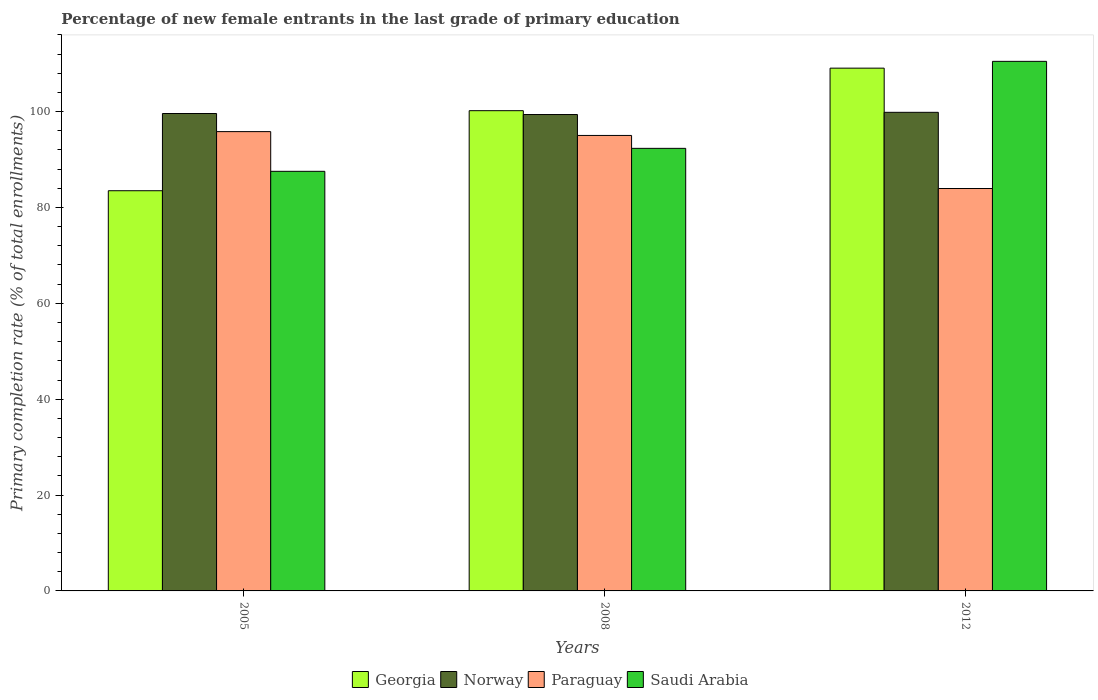How many different coloured bars are there?
Offer a very short reply. 4. How many bars are there on the 1st tick from the left?
Make the answer very short. 4. What is the label of the 2nd group of bars from the left?
Ensure brevity in your answer.  2008. In how many cases, is the number of bars for a given year not equal to the number of legend labels?
Your answer should be very brief. 0. What is the percentage of new female entrants in Georgia in 2008?
Your answer should be very brief. 100.19. Across all years, what is the maximum percentage of new female entrants in Paraguay?
Your answer should be very brief. 95.83. Across all years, what is the minimum percentage of new female entrants in Norway?
Offer a terse response. 99.39. What is the total percentage of new female entrants in Paraguay in the graph?
Provide a succinct answer. 274.82. What is the difference between the percentage of new female entrants in Norway in 2005 and that in 2012?
Make the answer very short. -0.25. What is the difference between the percentage of new female entrants in Georgia in 2008 and the percentage of new female entrants in Saudi Arabia in 2005?
Make the answer very short. 12.65. What is the average percentage of new female entrants in Paraguay per year?
Keep it short and to the point. 91.61. In the year 2008, what is the difference between the percentage of new female entrants in Saudi Arabia and percentage of new female entrants in Georgia?
Offer a very short reply. -7.86. What is the ratio of the percentage of new female entrants in Georgia in 2005 to that in 2012?
Keep it short and to the point. 0.77. Is the percentage of new female entrants in Norway in 2005 less than that in 2008?
Offer a terse response. No. What is the difference between the highest and the second highest percentage of new female entrants in Paraguay?
Your answer should be very brief. 0.8. What is the difference between the highest and the lowest percentage of new female entrants in Paraguay?
Ensure brevity in your answer.  11.87. In how many years, is the percentage of new female entrants in Paraguay greater than the average percentage of new female entrants in Paraguay taken over all years?
Make the answer very short. 2. Is the sum of the percentage of new female entrants in Norway in 2005 and 2008 greater than the maximum percentage of new female entrants in Georgia across all years?
Your answer should be compact. Yes. What does the 1st bar from the left in 2005 represents?
Your answer should be compact. Georgia. How many bars are there?
Your answer should be very brief. 12. How many years are there in the graph?
Your response must be concise. 3. Does the graph contain grids?
Your answer should be very brief. No. Where does the legend appear in the graph?
Your answer should be very brief. Bottom center. How are the legend labels stacked?
Offer a very short reply. Horizontal. What is the title of the graph?
Offer a terse response. Percentage of new female entrants in the last grade of primary education. What is the label or title of the X-axis?
Your answer should be compact. Years. What is the label or title of the Y-axis?
Provide a short and direct response. Primary completion rate (% of total enrollments). What is the Primary completion rate (% of total enrollments) of Georgia in 2005?
Give a very brief answer. 83.49. What is the Primary completion rate (% of total enrollments) of Norway in 2005?
Your answer should be compact. 99.61. What is the Primary completion rate (% of total enrollments) of Paraguay in 2005?
Give a very brief answer. 95.83. What is the Primary completion rate (% of total enrollments) in Saudi Arabia in 2005?
Your response must be concise. 87.54. What is the Primary completion rate (% of total enrollments) in Georgia in 2008?
Offer a terse response. 100.19. What is the Primary completion rate (% of total enrollments) of Norway in 2008?
Offer a terse response. 99.39. What is the Primary completion rate (% of total enrollments) of Paraguay in 2008?
Your answer should be very brief. 95.03. What is the Primary completion rate (% of total enrollments) of Saudi Arabia in 2008?
Your answer should be very brief. 92.34. What is the Primary completion rate (% of total enrollments) in Georgia in 2012?
Keep it short and to the point. 109.07. What is the Primary completion rate (% of total enrollments) of Norway in 2012?
Your answer should be compact. 99.85. What is the Primary completion rate (% of total enrollments) of Paraguay in 2012?
Give a very brief answer. 83.96. What is the Primary completion rate (% of total enrollments) in Saudi Arabia in 2012?
Your response must be concise. 110.49. Across all years, what is the maximum Primary completion rate (% of total enrollments) in Georgia?
Ensure brevity in your answer.  109.07. Across all years, what is the maximum Primary completion rate (% of total enrollments) of Norway?
Your answer should be compact. 99.85. Across all years, what is the maximum Primary completion rate (% of total enrollments) in Paraguay?
Ensure brevity in your answer.  95.83. Across all years, what is the maximum Primary completion rate (% of total enrollments) in Saudi Arabia?
Give a very brief answer. 110.49. Across all years, what is the minimum Primary completion rate (% of total enrollments) in Georgia?
Ensure brevity in your answer.  83.49. Across all years, what is the minimum Primary completion rate (% of total enrollments) in Norway?
Keep it short and to the point. 99.39. Across all years, what is the minimum Primary completion rate (% of total enrollments) in Paraguay?
Offer a very short reply. 83.96. Across all years, what is the minimum Primary completion rate (% of total enrollments) of Saudi Arabia?
Offer a terse response. 87.54. What is the total Primary completion rate (% of total enrollments) in Georgia in the graph?
Give a very brief answer. 292.76. What is the total Primary completion rate (% of total enrollments) of Norway in the graph?
Your response must be concise. 298.85. What is the total Primary completion rate (% of total enrollments) of Paraguay in the graph?
Offer a terse response. 274.82. What is the total Primary completion rate (% of total enrollments) in Saudi Arabia in the graph?
Your answer should be compact. 290.37. What is the difference between the Primary completion rate (% of total enrollments) in Georgia in 2005 and that in 2008?
Ensure brevity in your answer.  -16.7. What is the difference between the Primary completion rate (% of total enrollments) in Norway in 2005 and that in 2008?
Offer a terse response. 0.21. What is the difference between the Primary completion rate (% of total enrollments) in Paraguay in 2005 and that in 2008?
Provide a short and direct response. 0.8. What is the difference between the Primary completion rate (% of total enrollments) in Saudi Arabia in 2005 and that in 2008?
Provide a succinct answer. -4.79. What is the difference between the Primary completion rate (% of total enrollments) of Georgia in 2005 and that in 2012?
Ensure brevity in your answer.  -25.57. What is the difference between the Primary completion rate (% of total enrollments) of Norway in 2005 and that in 2012?
Ensure brevity in your answer.  -0.25. What is the difference between the Primary completion rate (% of total enrollments) in Paraguay in 2005 and that in 2012?
Offer a terse response. 11.87. What is the difference between the Primary completion rate (% of total enrollments) of Saudi Arabia in 2005 and that in 2012?
Offer a terse response. -22.94. What is the difference between the Primary completion rate (% of total enrollments) of Georgia in 2008 and that in 2012?
Your response must be concise. -8.87. What is the difference between the Primary completion rate (% of total enrollments) of Norway in 2008 and that in 2012?
Your response must be concise. -0.46. What is the difference between the Primary completion rate (% of total enrollments) of Paraguay in 2008 and that in 2012?
Offer a very short reply. 11.07. What is the difference between the Primary completion rate (% of total enrollments) of Saudi Arabia in 2008 and that in 2012?
Ensure brevity in your answer.  -18.15. What is the difference between the Primary completion rate (% of total enrollments) in Georgia in 2005 and the Primary completion rate (% of total enrollments) in Norway in 2008?
Provide a short and direct response. -15.9. What is the difference between the Primary completion rate (% of total enrollments) in Georgia in 2005 and the Primary completion rate (% of total enrollments) in Paraguay in 2008?
Provide a short and direct response. -11.54. What is the difference between the Primary completion rate (% of total enrollments) in Georgia in 2005 and the Primary completion rate (% of total enrollments) in Saudi Arabia in 2008?
Your answer should be compact. -8.84. What is the difference between the Primary completion rate (% of total enrollments) of Norway in 2005 and the Primary completion rate (% of total enrollments) of Paraguay in 2008?
Provide a succinct answer. 4.58. What is the difference between the Primary completion rate (% of total enrollments) of Norway in 2005 and the Primary completion rate (% of total enrollments) of Saudi Arabia in 2008?
Your response must be concise. 7.27. What is the difference between the Primary completion rate (% of total enrollments) of Paraguay in 2005 and the Primary completion rate (% of total enrollments) of Saudi Arabia in 2008?
Your answer should be compact. 3.49. What is the difference between the Primary completion rate (% of total enrollments) in Georgia in 2005 and the Primary completion rate (% of total enrollments) in Norway in 2012?
Make the answer very short. -16.36. What is the difference between the Primary completion rate (% of total enrollments) in Georgia in 2005 and the Primary completion rate (% of total enrollments) in Paraguay in 2012?
Give a very brief answer. -0.46. What is the difference between the Primary completion rate (% of total enrollments) of Georgia in 2005 and the Primary completion rate (% of total enrollments) of Saudi Arabia in 2012?
Your answer should be very brief. -26.99. What is the difference between the Primary completion rate (% of total enrollments) in Norway in 2005 and the Primary completion rate (% of total enrollments) in Paraguay in 2012?
Provide a succinct answer. 15.65. What is the difference between the Primary completion rate (% of total enrollments) in Norway in 2005 and the Primary completion rate (% of total enrollments) in Saudi Arabia in 2012?
Give a very brief answer. -10.88. What is the difference between the Primary completion rate (% of total enrollments) of Paraguay in 2005 and the Primary completion rate (% of total enrollments) of Saudi Arabia in 2012?
Provide a succinct answer. -14.66. What is the difference between the Primary completion rate (% of total enrollments) of Georgia in 2008 and the Primary completion rate (% of total enrollments) of Norway in 2012?
Give a very brief answer. 0.34. What is the difference between the Primary completion rate (% of total enrollments) of Georgia in 2008 and the Primary completion rate (% of total enrollments) of Paraguay in 2012?
Provide a short and direct response. 16.24. What is the difference between the Primary completion rate (% of total enrollments) of Georgia in 2008 and the Primary completion rate (% of total enrollments) of Saudi Arabia in 2012?
Ensure brevity in your answer.  -10.29. What is the difference between the Primary completion rate (% of total enrollments) in Norway in 2008 and the Primary completion rate (% of total enrollments) in Paraguay in 2012?
Offer a terse response. 15.43. What is the difference between the Primary completion rate (% of total enrollments) in Norway in 2008 and the Primary completion rate (% of total enrollments) in Saudi Arabia in 2012?
Provide a succinct answer. -11.09. What is the difference between the Primary completion rate (% of total enrollments) of Paraguay in 2008 and the Primary completion rate (% of total enrollments) of Saudi Arabia in 2012?
Provide a short and direct response. -15.46. What is the average Primary completion rate (% of total enrollments) in Georgia per year?
Provide a succinct answer. 97.59. What is the average Primary completion rate (% of total enrollments) in Norway per year?
Make the answer very short. 99.62. What is the average Primary completion rate (% of total enrollments) in Paraguay per year?
Ensure brevity in your answer.  91.61. What is the average Primary completion rate (% of total enrollments) in Saudi Arabia per year?
Your response must be concise. 96.79. In the year 2005, what is the difference between the Primary completion rate (% of total enrollments) in Georgia and Primary completion rate (% of total enrollments) in Norway?
Provide a short and direct response. -16.11. In the year 2005, what is the difference between the Primary completion rate (% of total enrollments) of Georgia and Primary completion rate (% of total enrollments) of Paraguay?
Ensure brevity in your answer.  -12.33. In the year 2005, what is the difference between the Primary completion rate (% of total enrollments) of Georgia and Primary completion rate (% of total enrollments) of Saudi Arabia?
Your answer should be compact. -4.05. In the year 2005, what is the difference between the Primary completion rate (% of total enrollments) in Norway and Primary completion rate (% of total enrollments) in Paraguay?
Ensure brevity in your answer.  3.78. In the year 2005, what is the difference between the Primary completion rate (% of total enrollments) in Norway and Primary completion rate (% of total enrollments) in Saudi Arabia?
Your response must be concise. 12.06. In the year 2005, what is the difference between the Primary completion rate (% of total enrollments) of Paraguay and Primary completion rate (% of total enrollments) of Saudi Arabia?
Offer a very short reply. 8.28. In the year 2008, what is the difference between the Primary completion rate (% of total enrollments) of Georgia and Primary completion rate (% of total enrollments) of Norway?
Make the answer very short. 0.8. In the year 2008, what is the difference between the Primary completion rate (% of total enrollments) in Georgia and Primary completion rate (% of total enrollments) in Paraguay?
Your answer should be compact. 5.16. In the year 2008, what is the difference between the Primary completion rate (% of total enrollments) in Georgia and Primary completion rate (% of total enrollments) in Saudi Arabia?
Your answer should be very brief. 7.86. In the year 2008, what is the difference between the Primary completion rate (% of total enrollments) of Norway and Primary completion rate (% of total enrollments) of Paraguay?
Ensure brevity in your answer.  4.36. In the year 2008, what is the difference between the Primary completion rate (% of total enrollments) in Norway and Primary completion rate (% of total enrollments) in Saudi Arabia?
Make the answer very short. 7.06. In the year 2008, what is the difference between the Primary completion rate (% of total enrollments) in Paraguay and Primary completion rate (% of total enrollments) in Saudi Arabia?
Your response must be concise. 2.69. In the year 2012, what is the difference between the Primary completion rate (% of total enrollments) in Georgia and Primary completion rate (% of total enrollments) in Norway?
Ensure brevity in your answer.  9.22. In the year 2012, what is the difference between the Primary completion rate (% of total enrollments) in Georgia and Primary completion rate (% of total enrollments) in Paraguay?
Offer a terse response. 25.11. In the year 2012, what is the difference between the Primary completion rate (% of total enrollments) in Georgia and Primary completion rate (% of total enrollments) in Saudi Arabia?
Your answer should be very brief. -1.42. In the year 2012, what is the difference between the Primary completion rate (% of total enrollments) in Norway and Primary completion rate (% of total enrollments) in Paraguay?
Keep it short and to the point. 15.89. In the year 2012, what is the difference between the Primary completion rate (% of total enrollments) of Norway and Primary completion rate (% of total enrollments) of Saudi Arabia?
Keep it short and to the point. -10.63. In the year 2012, what is the difference between the Primary completion rate (% of total enrollments) in Paraguay and Primary completion rate (% of total enrollments) in Saudi Arabia?
Offer a terse response. -26.53. What is the ratio of the Primary completion rate (% of total enrollments) in Norway in 2005 to that in 2008?
Offer a terse response. 1. What is the ratio of the Primary completion rate (% of total enrollments) of Paraguay in 2005 to that in 2008?
Your response must be concise. 1.01. What is the ratio of the Primary completion rate (% of total enrollments) in Saudi Arabia in 2005 to that in 2008?
Keep it short and to the point. 0.95. What is the ratio of the Primary completion rate (% of total enrollments) of Georgia in 2005 to that in 2012?
Provide a short and direct response. 0.77. What is the ratio of the Primary completion rate (% of total enrollments) of Norway in 2005 to that in 2012?
Your answer should be compact. 1. What is the ratio of the Primary completion rate (% of total enrollments) of Paraguay in 2005 to that in 2012?
Your answer should be very brief. 1.14. What is the ratio of the Primary completion rate (% of total enrollments) in Saudi Arabia in 2005 to that in 2012?
Offer a terse response. 0.79. What is the ratio of the Primary completion rate (% of total enrollments) in Georgia in 2008 to that in 2012?
Make the answer very short. 0.92. What is the ratio of the Primary completion rate (% of total enrollments) of Norway in 2008 to that in 2012?
Give a very brief answer. 1. What is the ratio of the Primary completion rate (% of total enrollments) of Paraguay in 2008 to that in 2012?
Provide a succinct answer. 1.13. What is the ratio of the Primary completion rate (% of total enrollments) of Saudi Arabia in 2008 to that in 2012?
Your response must be concise. 0.84. What is the difference between the highest and the second highest Primary completion rate (% of total enrollments) in Georgia?
Ensure brevity in your answer.  8.87. What is the difference between the highest and the second highest Primary completion rate (% of total enrollments) in Norway?
Provide a succinct answer. 0.25. What is the difference between the highest and the second highest Primary completion rate (% of total enrollments) in Paraguay?
Keep it short and to the point. 0.8. What is the difference between the highest and the second highest Primary completion rate (% of total enrollments) of Saudi Arabia?
Ensure brevity in your answer.  18.15. What is the difference between the highest and the lowest Primary completion rate (% of total enrollments) in Georgia?
Your answer should be very brief. 25.57. What is the difference between the highest and the lowest Primary completion rate (% of total enrollments) in Norway?
Offer a terse response. 0.46. What is the difference between the highest and the lowest Primary completion rate (% of total enrollments) in Paraguay?
Make the answer very short. 11.87. What is the difference between the highest and the lowest Primary completion rate (% of total enrollments) of Saudi Arabia?
Your answer should be very brief. 22.94. 